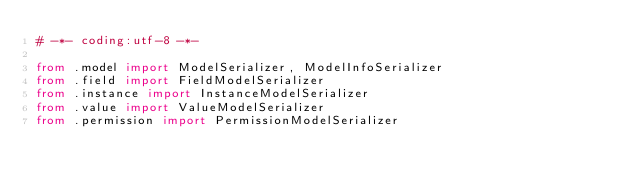<code> <loc_0><loc_0><loc_500><loc_500><_Python_># -*- coding:utf-8 -*-

from .model import ModelSerializer, ModelInfoSerializer
from .field import FieldModelSerializer
from .instance import InstanceModelSerializer
from .value import ValueModelSerializer
from .permission import PermissionModelSerializer

</code> 